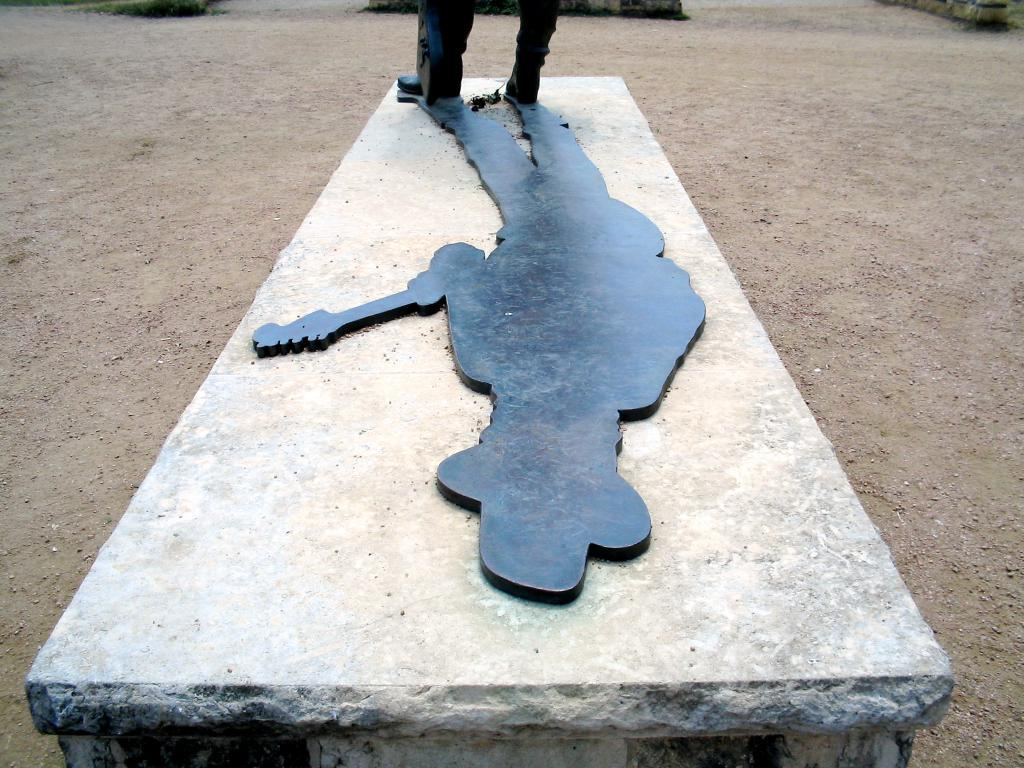What is present on the wall in the image? There is a sculpture on the wall in the image. Can you describe the area around the sculpture? The ground is visible around the sculpture. What is the most efficient route to take while playing basketball in the image? There is no basketball or route present in the image; it features a wall with a sculpture on it and the ground visible around the sculpture. 